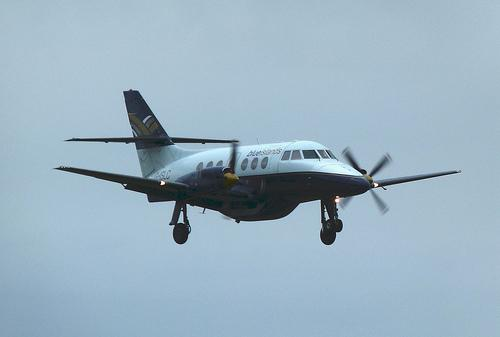How many window seats can be observed on the plane? There are many window seats on the side of the plane, with 78 window seats observed. Mention any company branding or identification details visible on the plane. The plane has airline branding, a company name in blue and red, and identification information in black letters. What can be observed about the plane's landing gear? The plane has three wheels lowered, which includes a right landing gear, left landing gear, and a large black plane wheel. List three distinct features present in the cockpit area of the plane. The pilot window, front windshields, and curving cockpit windows are distinct features in the cockpit area. How many propellers can be seen on the plane, and where are they located? There is one four-blade propeller in motion, located on the front of the plane. Briefly describe the color scheme of the plane's tail. The tail of the plane has green and white stripes on a dark background, and gold and blue color. What type of transportation is prominent in the image? A small personal airplane is the prominent mode of transportation in the image. Provide a general summary of the image, including the plane's position. The image shows a flying plane with a white and blue color scheme against light blue skies, featuring various elements such as windows, propellers, and landing gear. Identify the different types of windows visible on the plane. Oval passenger windows, window seats, round window, front square windows, and windows on the front of the cockpit are visible on the plane. What details can be observed about the plane's wings? The plane has long wings, and an engine on both the right wing and left wing, along with visibility lights. 